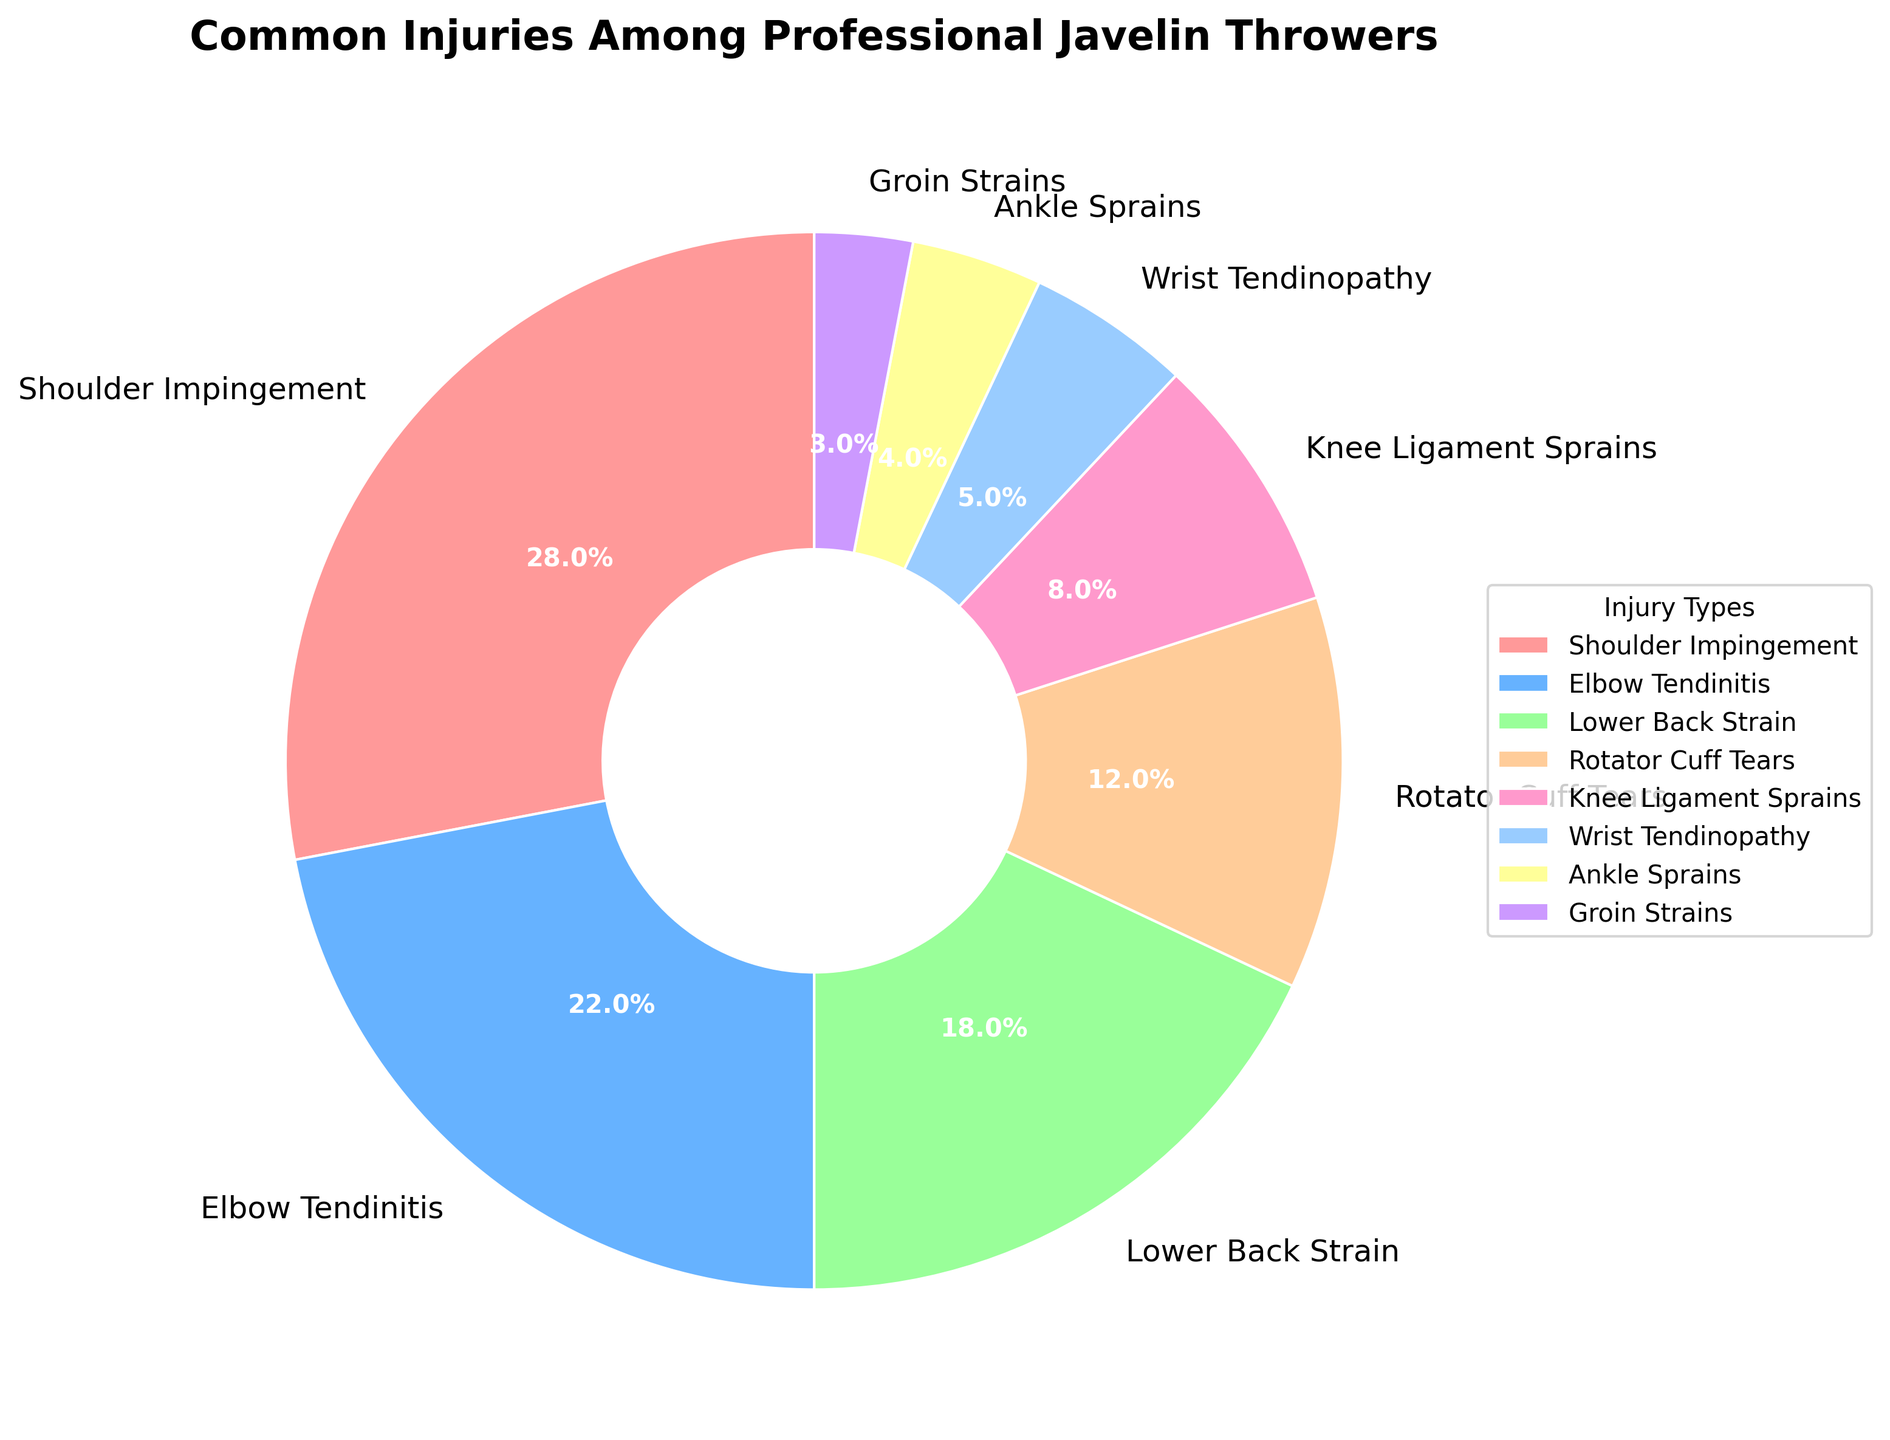What's the most common injury among professional javelin throwers? The largest segment in the pie chart represents the most common injury. Shoulder Impingement has the largest segment in the pie chart.
Answer: Shoulder Impingement Which injury type is less frequent, Knee Ligament Sprains or Rotator Cuff Tears? Knee Ligament Sprains are shown to have 8%, while Rotator Cuff Tears have 12%. Since 8% is less than 12%, Knee Ligament Sprains are less frequent.
Answer: Knee Ligament Sprains What's the sum percentage of Elbow Tendinitis and Shoulder Impingement? Sum the percentages of Elbow Tendinitis (22%) and Shoulder Impingement (28%) by adding 22 + 28.
Answer: 50% Compare the frequency of Lower Back Strain to Wrist Tendinopathy. Which one is more common? Lower Back Strain has a percentage of 18%, while Wrist Tendinopathy has 5%. Since 18% is greater than 5%, Lower Back Strain is more common.
Answer: Lower Back Strain Which injury type has the smallest segment on the pie chart? The segment with the smallest percentage is the smallest segment. Groin Strains have the smallest segment at 3%.
Answer: Groin Strains What is the combined percentage of injuries affecting the upper body (Shoulder Impingement, Elbow Tendinitis, Rotator Cuff Tears, Wrist Tendinopathy)? Add the percentages of Shoulder Impingement (28%), Elbow Tendinitis (22%), Rotator Cuff Tears (12%), and Wrist Tendinopathy (5%) by summing 28 + 22 + 12 + 5.
Answer: 67% How much more frequent are Shoulder Impingement injuries compared to Ankle Sprains? The percentage for Shoulder Impingement is 28%, and for Ankle Sprains it is 4%. Subtract 4 from 28 to find the difference. 28 - 4 = 24.
Answer: 24% Are Lower Back Strain injuries more frequent than Knee Ligament Sprains and Groin Strains combined? Lower Back Strain is 18%. Combine the percentages of Knee Ligament Sprains (8%) and Groin Strains (3%) by adding 8 + 3 = 11%. Since 18% is greater than 11%, Lower Back Strains are more frequent.
Answer: Yes If one more injury category was added equally splitting the "Shoulder Impingement" segment, what would be the new percentage for this injury type? Shoulder Impingement is currently 28%. If we split it equally, the new percentage would be 28 / 2 by dividing by 2.
Answer: 14% What percentage of injuries are lower body injuries (Lower Back Strain, Knee Ligament Sprains, Ankle Sprains, Groin Strains)? Add the percentages for Lower Back Strain (18%), Knee Ligament Sprains (8%), Ankle Sprains (4%), and Groin Strains (3%) by summing 18 + 8 + 4 + 3.
Answer: 33% 